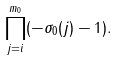<formula> <loc_0><loc_0><loc_500><loc_500>\prod _ { j = i } ^ { m _ { 0 } } ( - \sigma _ { 0 } ( j ) - 1 ) .</formula> 